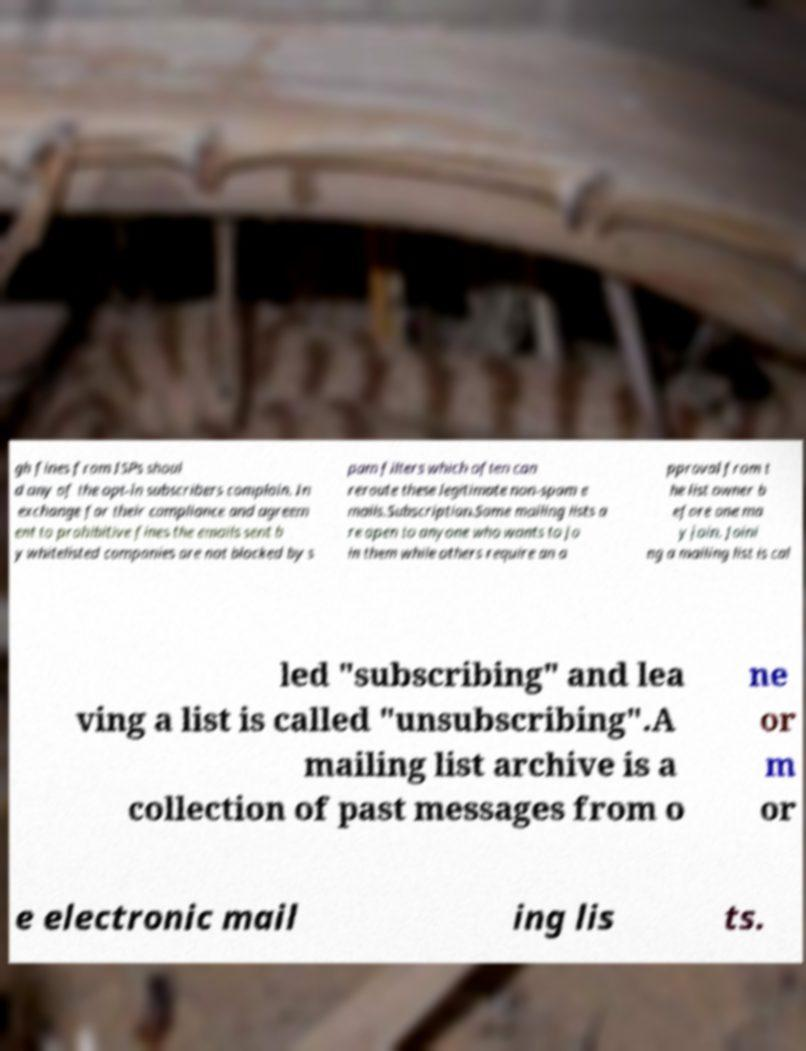Please identify and transcribe the text found in this image. gh fines from ISPs shoul d any of the opt-in subscribers complain. In exchange for their compliance and agreem ent to prohibitive fines the emails sent b y whitelisted companies are not blocked by s pam filters which often can reroute these legitimate non-spam e mails.Subscription.Some mailing lists a re open to anyone who wants to jo in them while others require an a pproval from t he list owner b efore one ma y join. Joini ng a mailing list is cal led "subscribing" and lea ving a list is called "unsubscribing".A mailing list archive is a collection of past messages from o ne or m or e electronic mail ing lis ts. 